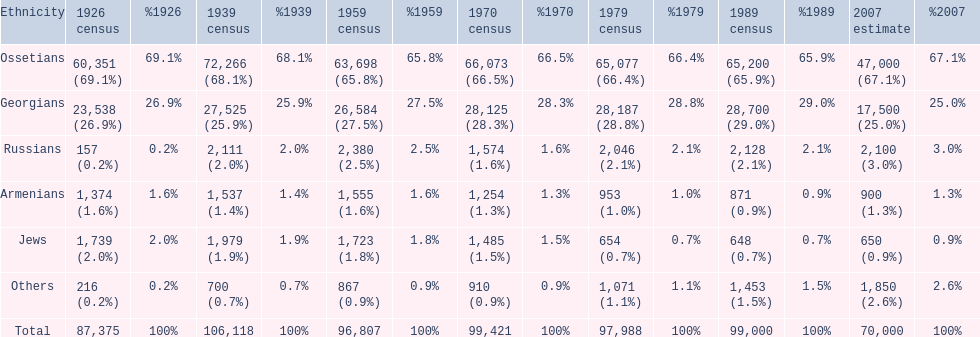How many ethnicities were below 1,000 people in 2007? 2. 